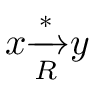Convert formula to latex. <formula><loc_0><loc_0><loc_500><loc_500>x { \xrightarrow [ { R } ] { * } } y</formula> 